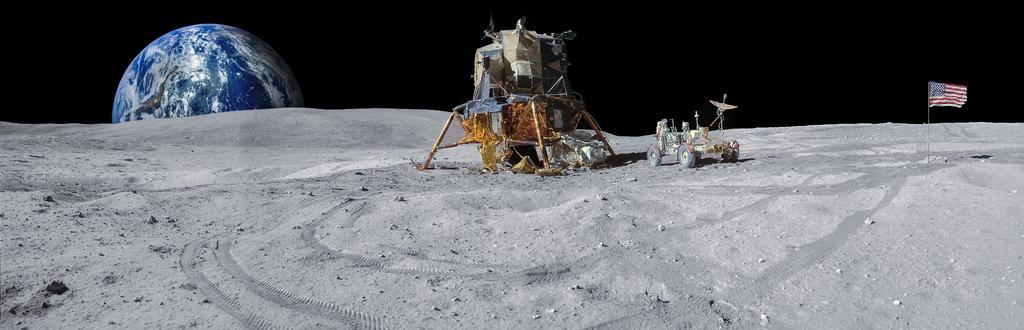Describe this image in one or two sentences. This image looks like it is clicked on the mars. In the front, we can see a vehicle. On the right, there is a flag. On the left, we can see a globe. At the bottom, there is sand. 